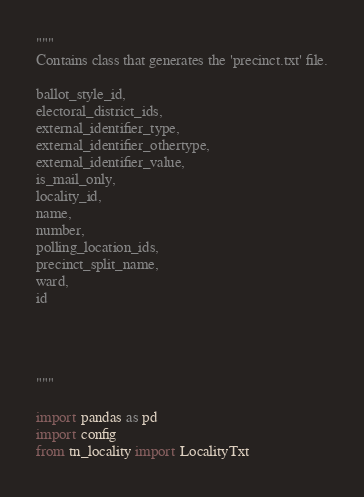Convert code to text. <code><loc_0><loc_0><loc_500><loc_500><_Python_>"""
Contains class that generates the 'precinct.txt' file.

ballot_style_id,
electoral_district_ids,
external_identifier_type,
external_identifier_othertype,
external_identifier_value,
is_mail_only,
locality_id,
name,
number,
polling_location_ids,
precinct_split_name,
ward,
id




"""

import pandas as pd
import config
from tn_locality import LocalityTxt</code> 